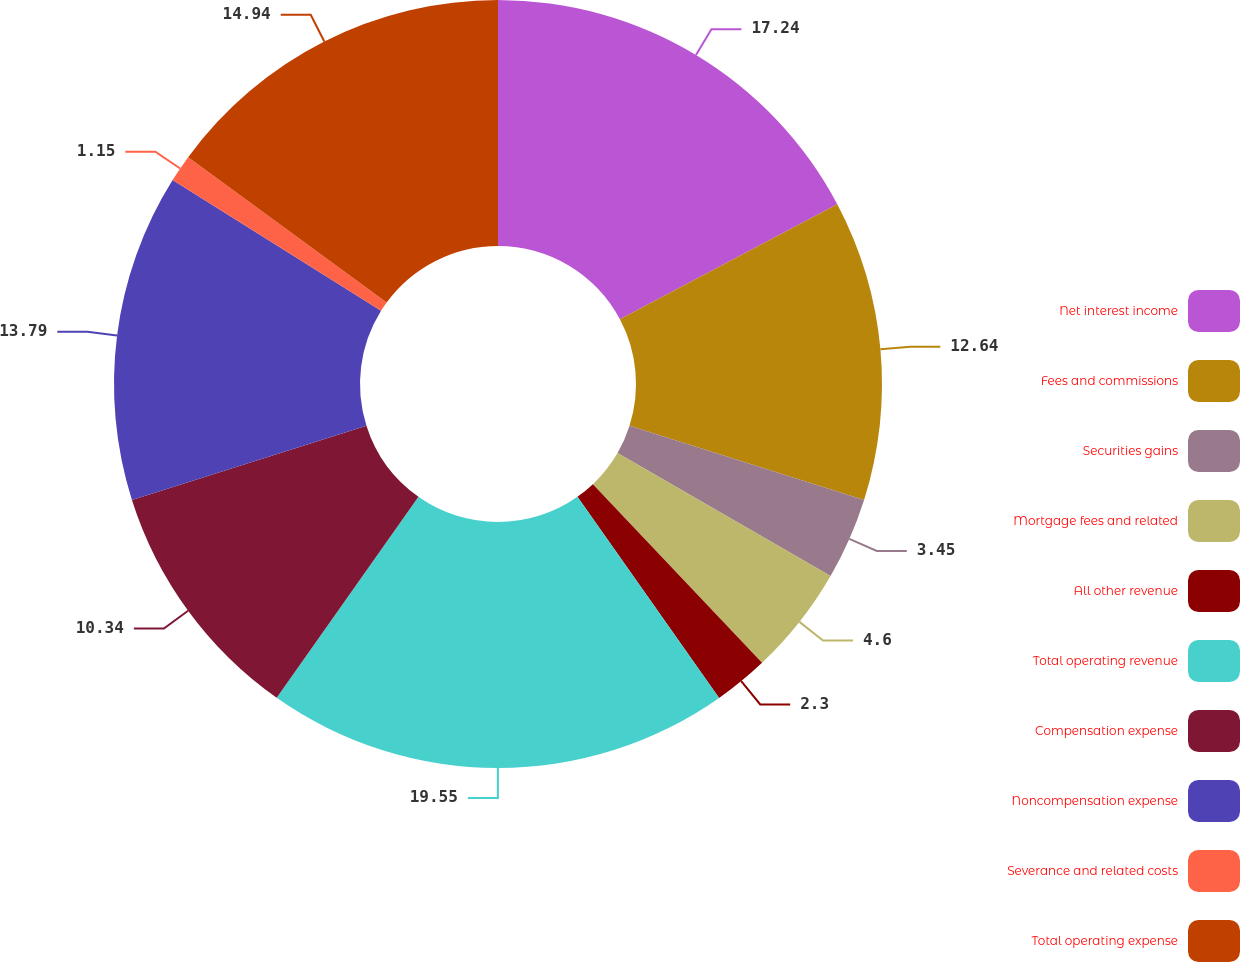Convert chart. <chart><loc_0><loc_0><loc_500><loc_500><pie_chart><fcel>Net interest income<fcel>Fees and commissions<fcel>Securities gains<fcel>Mortgage fees and related<fcel>All other revenue<fcel>Total operating revenue<fcel>Compensation expense<fcel>Noncompensation expense<fcel>Severance and related costs<fcel>Total operating expense<nl><fcel>17.24%<fcel>12.64%<fcel>3.45%<fcel>4.6%<fcel>2.3%<fcel>19.54%<fcel>10.34%<fcel>13.79%<fcel>1.15%<fcel>14.94%<nl></chart> 